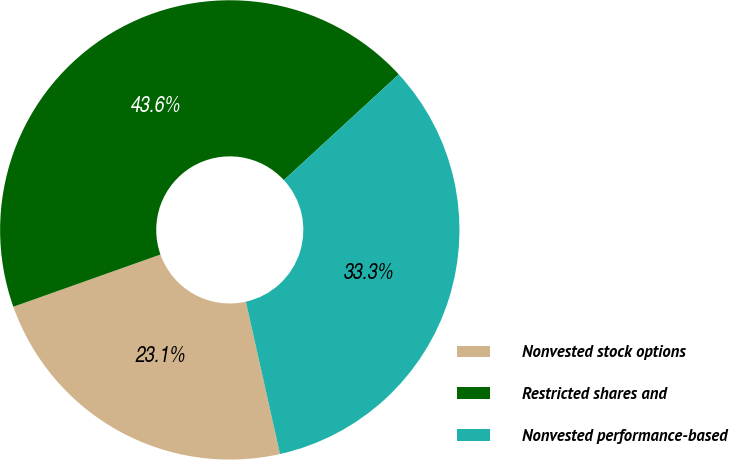Convert chart to OTSL. <chart><loc_0><loc_0><loc_500><loc_500><pie_chart><fcel>Nonvested stock options<fcel>Restricted shares and<fcel>Nonvested performance-based<nl><fcel>23.08%<fcel>43.59%<fcel>33.33%<nl></chart> 